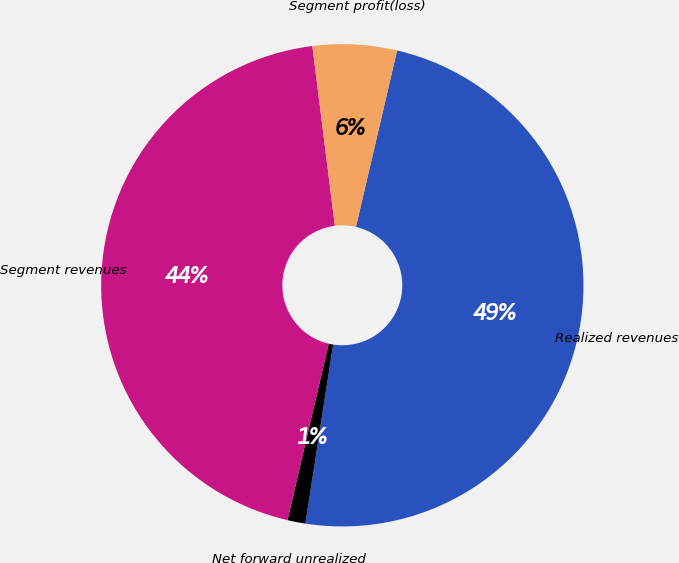Convert chart. <chart><loc_0><loc_0><loc_500><loc_500><pie_chart><fcel>Realized revenues<fcel>Net forward unrealized<fcel>Segment revenues<fcel>Segment profit(loss)<nl><fcel>48.8%<fcel>1.2%<fcel>44.37%<fcel>5.63%<nl></chart> 